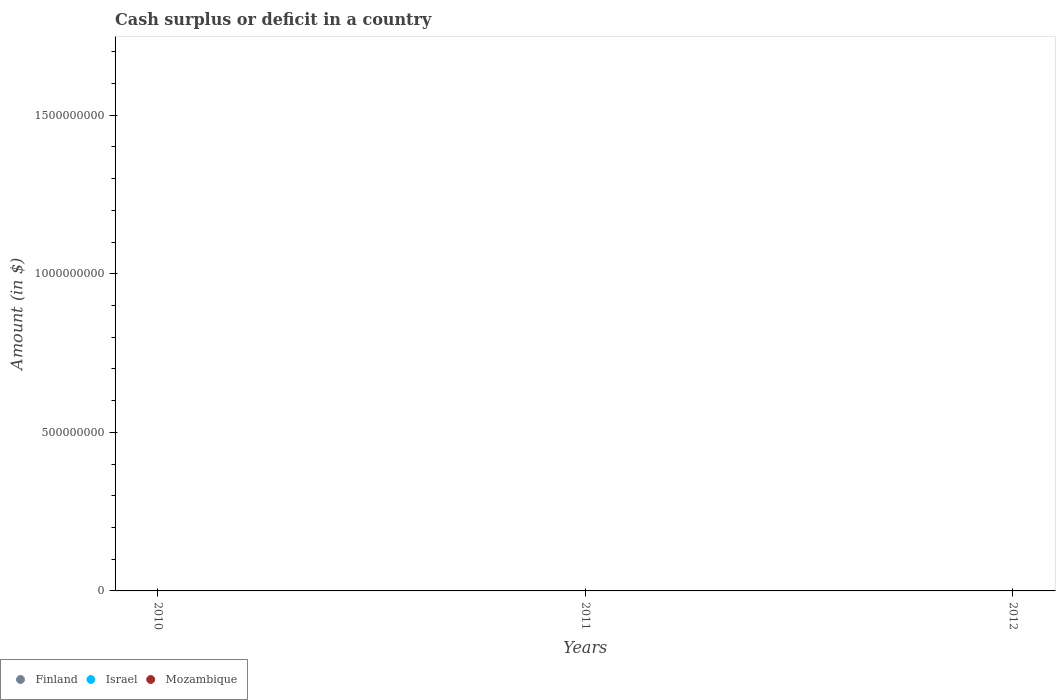What is the amount of cash surplus or deficit in Israel in 2011?
Offer a terse response. 0. What is the total amount of cash surplus or deficit in Israel in the graph?
Provide a short and direct response. 0. What is the average amount of cash surplus or deficit in Mozambique per year?
Provide a short and direct response. 0. In how many years, is the amount of cash surplus or deficit in Finland greater than the average amount of cash surplus or deficit in Finland taken over all years?
Provide a succinct answer. 0. Is it the case that in every year, the sum of the amount of cash surplus or deficit in Mozambique and amount of cash surplus or deficit in Israel  is greater than the amount of cash surplus or deficit in Finland?
Make the answer very short. No. Does the amount of cash surplus or deficit in Mozambique monotonically increase over the years?
Offer a very short reply. No. How many years are there in the graph?
Offer a very short reply. 3. Does the graph contain any zero values?
Make the answer very short. Yes. Does the graph contain grids?
Offer a very short reply. No. Where does the legend appear in the graph?
Provide a succinct answer. Bottom left. How many legend labels are there?
Provide a succinct answer. 3. What is the title of the graph?
Provide a succinct answer. Cash surplus or deficit in a country. Does "Namibia" appear as one of the legend labels in the graph?
Your answer should be compact. No. What is the label or title of the X-axis?
Provide a succinct answer. Years. What is the label or title of the Y-axis?
Offer a very short reply. Amount (in $). What is the Amount (in $) of Finland in 2010?
Keep it short and to the point. 0. What is the Amount (in $) in Israel in 2010?
Your answer should be very brief. 0. What is the Amount (in $) in Israel in 2011?
Your answer should be compact. 0. What is the Amount (in $) in Finland in 2012?
Give a very brief answer. 0. What is the Amount (in $) in Mozambique in 2012?
Keep it short and to the point. 0. What is the total Amount (in $) in Finland in the graph?
Give a very brief answer. 0. What is the total Amount (in $) of Israel in the graph?
Ensure brevity in your answer.  0. What is the average Amount (in $) in Israel per year?
Provide a succinct answer. 0. What is the average Amount (in $) in Mozambique per year?
Your response must be concise. 0. 